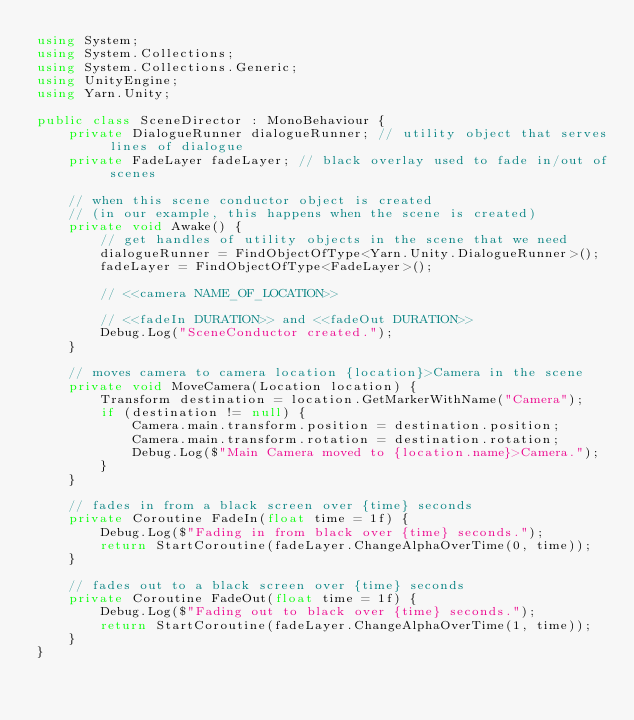Convert code to text. <code><loc_0><loc_0><loc_500><loc_500><_C#_>using System;
using System.Collections;
using System.Collections.Generic;
using UnityEngine;
using Yarn.Unity;

public class SceneDirector : MonoBehaviour {
    private DialogueRunner dialogueRunner; // utility object that serves lines of dialogue
    private FadeLayer fadeLayer; // black overlay used to fade in/out of scenes

    // when this scene conductor object is created
    // (in our example, this happens when the scene is created)
    private void Awake() {
        // get handles of utility objects in the scene that we need
        dialogueRunner = FindObjectOfType<Yarn.Unity.DialogueRunner>();
        fadeLayer = FindObjectOfType<FadeLayer>();

        // <<camera NAME_OF_LOCATION>>

        // <<fadeIn DURATION>> and <<fadeOut DURATION>>
        Debug.Log("SceneConductor created.");
    }

    // moves camera to camera location {location}>Camera in the scene
    private void MoveCamera(Location location) {
        Transform destination = location.GetMarkerWithName("Camera");
        if (destination != null) {
            Camera.main.transform.position = destination.position;
            Camera.main.transform.rotation = destination.rotation;
            Debug.Log($"Main Camera moved to {location.name}>Camera.");
        }
    }

    // fades in from a black screen over {time} seconds
    private Coroutine FadeIn(float time = 1f) {
        Debug.Log($"Fading in from black over {time} seconds.");
        return StartCoroutine(fadeLayer.ChangeAlphaOverTime(0, time));
    }

    // fades out to a black screen over {time} seconds
    private Coroutine FadeOut(float time = 1f) {
        Debug.Log($"Fading out to black over {time} seconds.");
        return StartCoroutine(fadeLayer.ChangeAlphaOverTime(1, time));
    }
}</code> 